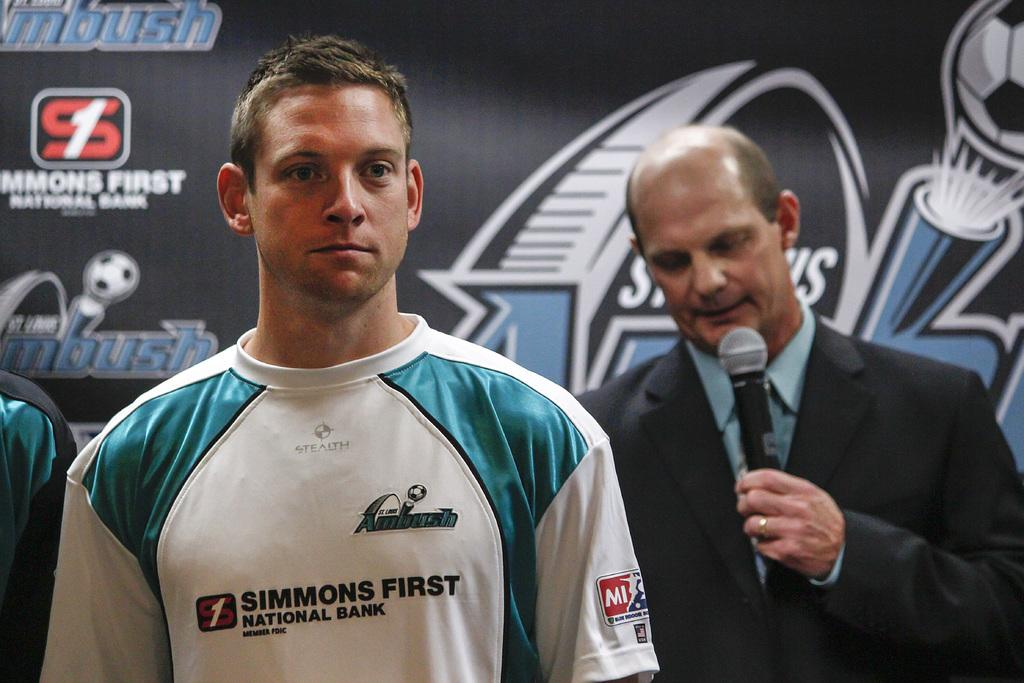<image>
Present a compact description of the photo's key features. A man in a white and blue shirt with a logo taht reads simmons first national bank on his chest. 